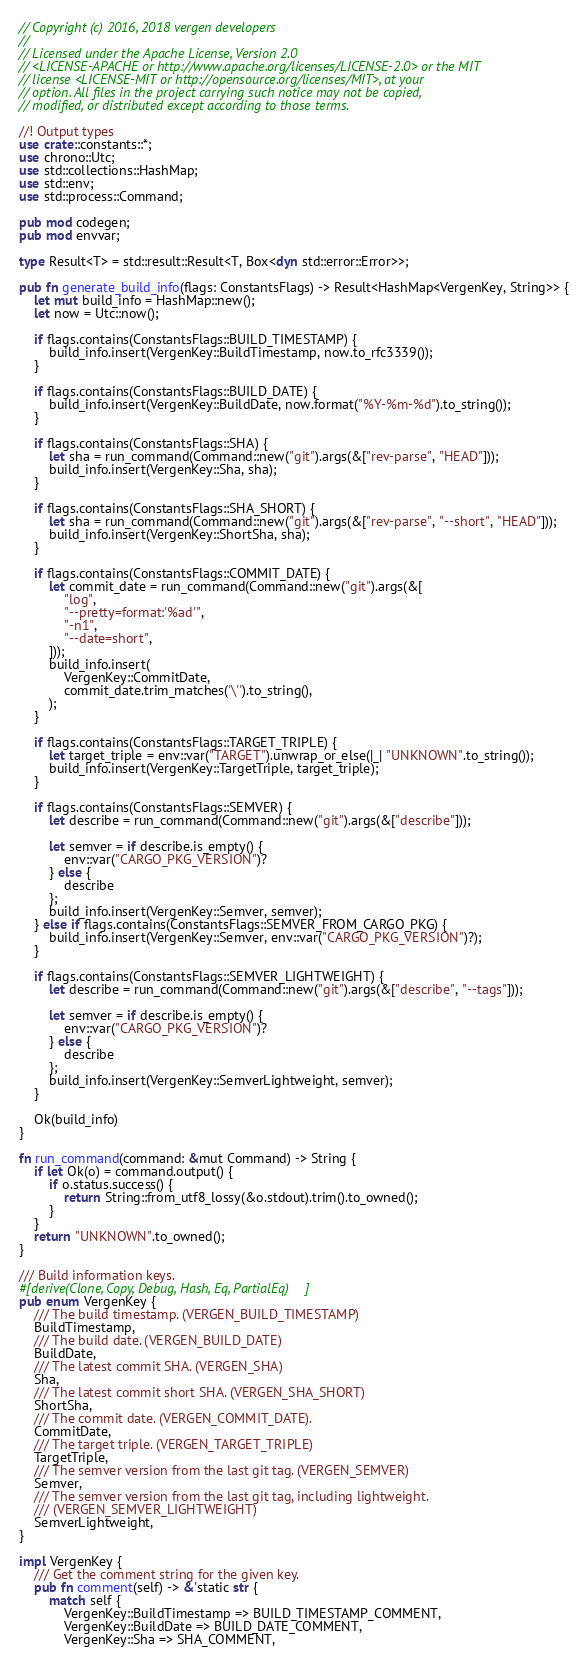Convert code to text. <code><loc_0><loc_0><loc_500><loc_500><_Rust_>// Copyright (c) 2016, 2018 vergen developers
//
// Licensed under the Apache License, Version 2.0
// <LICENSE-APACHE or http://www.apache.org/licenses/LICENSE-2.0> or the MIT
// license <LICENSE-MIT or http://opensource.org/licenses/MIT>, at your
// option. All files in the project carrying such notice may not be copied,
// modified, or distributed except according to those terms.

//! Output types
use crate::constants::*;
use chrono::Utc;
use std::collections::HashMap;
use std::env;
use std::process::Command;

pub mod codegen;
pub mod envvar;

type Result<T> = std::result::Result<T, Box<dyn std::error::Error>>;

pub fn generate_build_info(flags: ConstantsFlags) -> Result<HashMap<VergenKey, String>> {
    let mut build_info = HashMap::new();
    let now = Utc::now();

    if flags.contains(ConstantsFlags::BUILD_TIMESTAMP) {
        build_info.insert(VergenKey::BuildTimestamp, now.to_rfc3339());
    }

    if flags.contains(ConstantsFlags::BUILD_DATE) {
        build_info.insert(VergenKey::BuildDate, now.format("%Y-%m-%d").to_string());
    }

    if flags.contains(ConstantsFlags::SHA) {
        let sha = run_command(Command::new("git").args(&["rev-parse", "HEAD"]));
        build_info.insert(VergenKey::Sha, sha);
    }

    if flags.contains(ConstantsFlags::SHA_SHORT) {
        let sha = run_command(Command::new("git").args(&["rev-parse", "--short", "HEAD"]));
        build_info.insert(VergenKey::ShortSha, sha);
    }

    if flags.contains(ConstantsFlags::COMMIT_DATE) {
        let commit_date = run_command(Command::new("git").args(&[
            "log",
            "--pretty=format:'%ad'",
            "-n1",
            "--date=short",
        ]));
        build_info.insert(
            VergenKey::CommitDate,
            commit_date.trim_matches('\'').to_string(),
        );
    }

    if flags.contains(ConstantsFlags::TARGET_TRIPLE) {
        let target_triple = env::var("TARGET").unwrap_or_else(|_| "UNKNOWN".to_string());
        build_info.insert(VergenKey::TargetTriple, target_triple);
    }

    if flags.contains(ConstantsFlags::SEMVER) {
        let describe = run_command(Command::new("git").args(&["describe"]));

        let semver = if describe.is_empty() {
            env::var("CARGO_PKG_VERSION")?
        } else {
            describe
        };
        build_info.insert(VergenKey::Semver, semver);
    } else if flags.contains(ConstantsFlags::SEMVER_FROM_CARGO_PKG) {
        build_info.insert(VergenKey::Semver, env::var("CARGO_PKG_VERSION")?);
    }

    if flags.contains(ConstantsFlags::SEMVER_LIGHTWEIGHT) {
        let describe = run_command(Command::new("git").args(&["describe", "--tags"]));

        let semver = if describe.is_empty() {
            env::var("CARGO_PKG_VERSION")?
        } else {
            describe
        };
        build_info.insert(VergenKey::SemverLightweight, semver);
    }

    Ok(build_info)
}

fn run_command(command: &mut Command) -> String {
    if let Ok(o) = command.output() {
        if o.status.success() {
            return String::from_utf8_lossy(&o.stdout).trim().to_owned();
        }
    }
    return "UNKNOWN".to_owned();
}

/// Build information keys.
#[derive(Clone, Copy, Debug, Hash, Eq, PartialEq)]
pub enum VergenKey {
    /// The build timestamp. (VERGEN_BUILD_TIMESTAMP)
    BuildTimestamp,
    /// The build date. (VERGEN_BUILD_DATE)
    BuildDate,
    /// The latest commit SHA. (VERGEN_SHA)
    Sha,
    /// The latest commit short SHA. (VERGEN_SHA_SHORT)
    ShortSha,
    /// The commit date. (VERGEN_COMMIT_DATE).
    CommitDate,
    /// The target triple. (VERGEN_TARGET_TRIPLE)
    TargetTriple,
    /// The semver version from the last git tag. (VERGEN_SEMVER)
    Semver,
    /// The semver version from the last git tag, including lightweight.
    /// (VERGEN_SEMVER_LIGHTWEIGHT)
    SemverLightweight,
}

impl VergenKey {
    /// Get the comment string for the given key.
    pub fn comment(self) -> &'static str {
        match self {
            VergenKey::BuildTimestamp => BUILD_TIMESTAMP_COMMENT,
            VergenKey::BuildDate => BUILD_DATE_COMMENT,
            VergenKey::Sha => SHA_COMMENT,</code> 